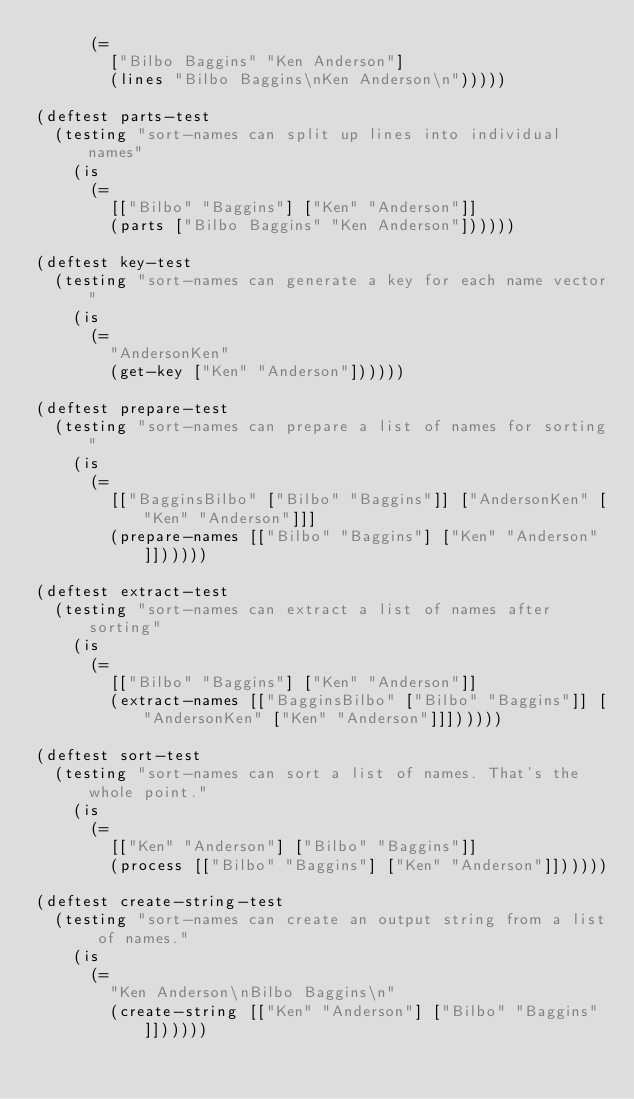Convert code to text. <code><loc_0><loc_0><loc_500><loc_500><_Clojure_>      (= 
        ["Bilbo Baggins" "Ken Anderson"]
        (lines "Bilbo Baggins\nKen Anderson\n")))))

(deftest parts-test
  (testing "sort-names can split up lines into individual names"
    (is
      (=
        [["Bilbo" "Baggins"] ["Ken" "Anderson"]]
        (parts ["Bilbo Baggins" "Ken Anderson"]))))) 

(deftest key-test
  (testing "sort-names can generate a key for each name vector"
    (is
      (=
        "AndersonKen"
        (get-key ["Ken" "Anderson"])))))
  
(deftest prepare-test
  (testing "sort-names can prepare a list of names for sorting"
    (is
      (=
        [["BagginsBilbo" ["Bilbo" "Baggins"]] ["AndersonKen" ["Ken" "Anderson"]]]
        (prepare-names [["Bilbo" "Baggins"] ["Ken" "Anderson"]])))))

(deftest extract-test
  (testing "sort-names can extract a list of names after sorting"
    (is
      (=
        [["Bilbo" "Baggins"] ["Ken" "Anderson"]]
        (extract-names [["BagginsBilbo" ["Bilbo" "Baggins"]] ["AndersonKen" ["Ken" "Anderson"]]])))))

(deftest sort-test
  (testing "sort-names can sort a list of names. That's the whole point."
    (is
      (=
        [["Ken" "Anderson"] ["Bilbo" "Baggins"]]
        (process [["Bilbo" "Baggins"] ["Ken" "Anderson"]])))))

(deftest create-string-test
  (testing "sort-names can create an output string from a list of names."
    (is
      (=
        "Ken Anderson\nBilbo Baggins\n"
        (create-string [["Ken" "Anderson"] ["Bilbo" "Baggins"]])))))
</code> 